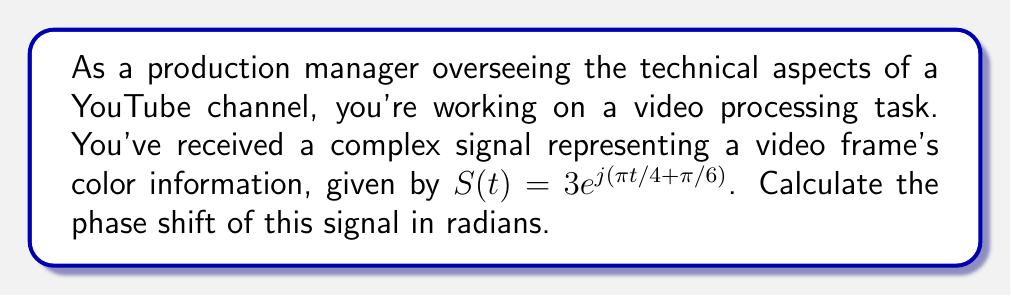What is the answer to this math problem? To find the phase shift of a complex signal, we need to analyze its exponential form. The general form of a complex signal is:

$$S(t) = Ae^{j(\omega t + \phi)}$$

Where:
- $A$ is the amplitude
- $\omega$ is the angular frequency
- $\phi$ is the phase shift

In our case, $S(t) = 3e^{j(\pi t/4 + \pi/6)}$

Comparing this to the general form, we can identify:
- $A = 3$
- $\omega t = \pi t/4$
- $\phi = \pi/6$

The phase shift is represented by $\phi$, which in this case is $\pi/6$ radians.

This phase shift indicates the initial angle of the signal at $t=0$. In video processing, it can affect the timing and synchronization of color information, potentially impacting the overall video quality and color accuracy.
Answer: The phase shift of the complex signal is $\frac{\pi}{6}$ radians. 